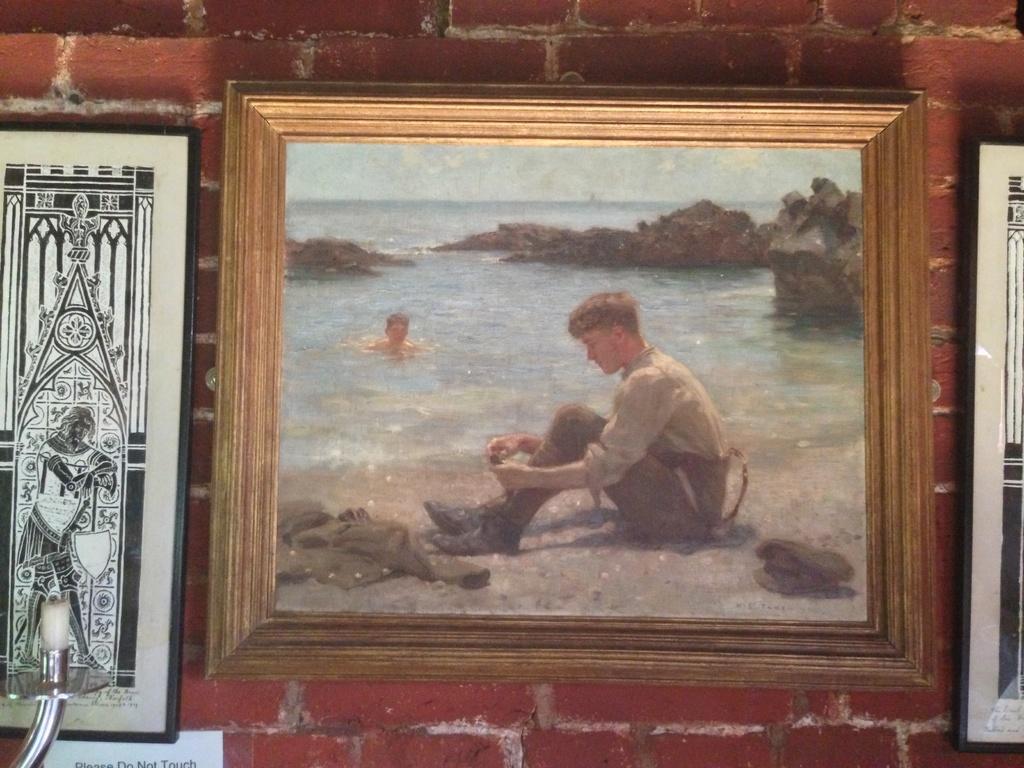Describe this image in one or two sentences. In this image there are three frames attached to the wall, in one frame there is a person sitting on the seashore, another person in water, rocks, sky. 